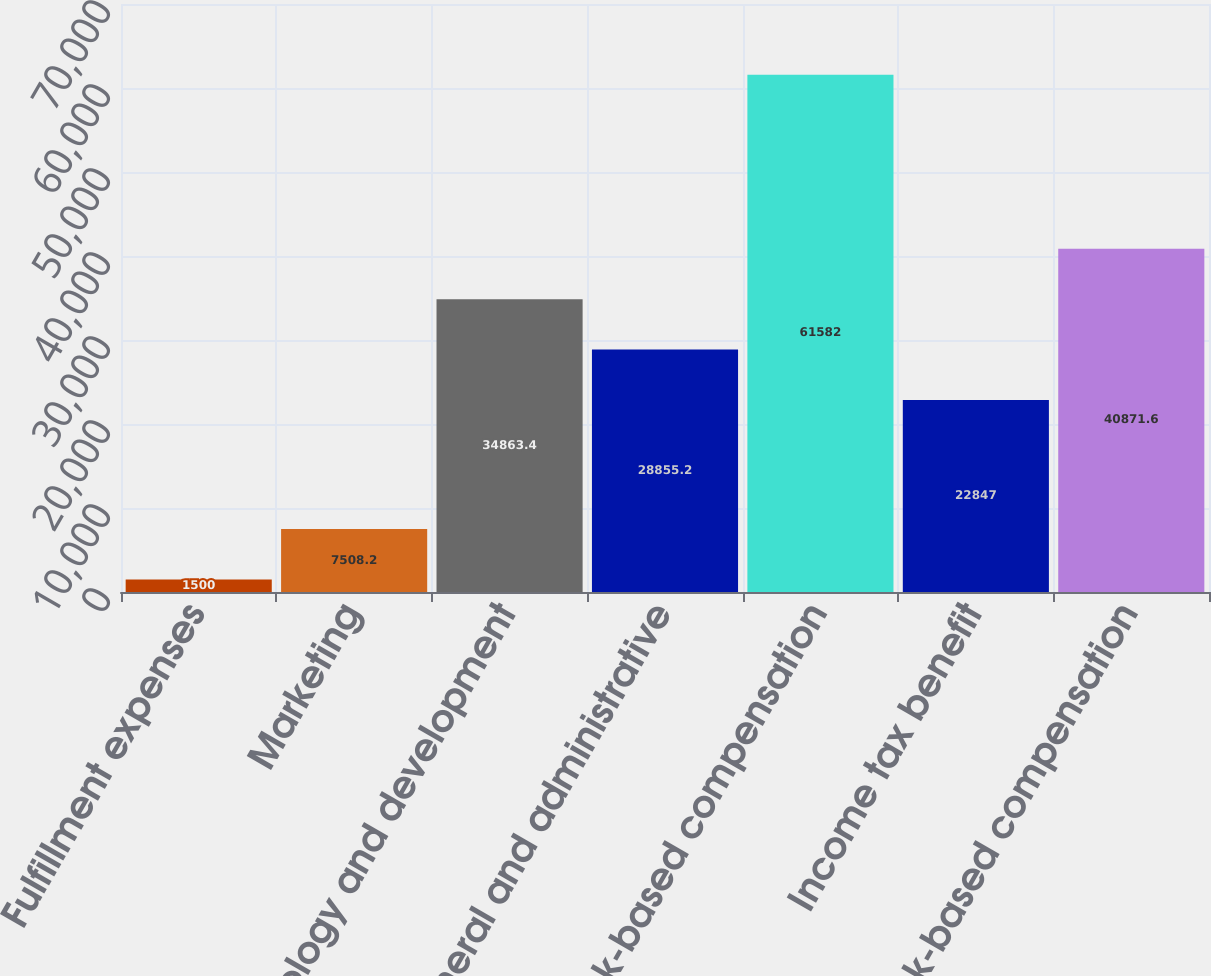Convert chart. <chart><loc_0><loc_0><loc_500><loc_500><bar_chart><fcel>Fulfillment expenses<fcel>Marketing<fcel>Technology and development<fcel>General and administrative<fcel>Stock-based compensation<fcel>Income tax benefit<fcel>Total stock-based compensation<nl><fcel>1500<fcel>7508.2<fcel>34863.4<fcel>28855.2<fcel>61582<fcel>22847<fcel>40871.6<nl></chart> 